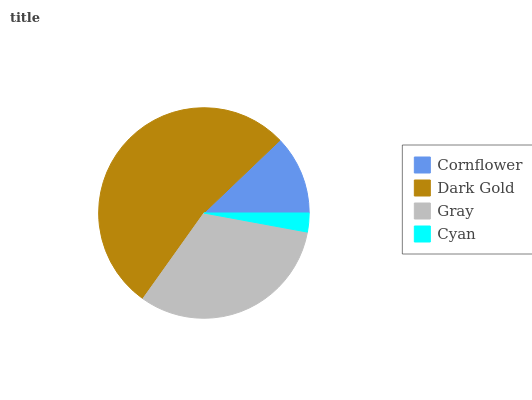Is Cyan the minimum?
Answer yes or no. Yes. Is Dark Gold the maximum?
Answer yes or no. Yes. Is Gray the minimum?
Answer yes or no. No. Is Gray the maximum?
Answer yes or no. No. Is Dark Gold greater than Gray?
Answer yes or no. Yes. Is Gray less than Dark Gold?
Answer yes or no. Yes. Is Gray greater than Dark Gold?
Answer yes or no. No. Is Dark Gold less than Gray?
Answer yes or no. No. Is Gray the high median?
Answer yes or no. Yes. Is Cornflower the low median?
Answer yes or no. Yes. Is Cyan the high median?
Answer yes or no. No. Is Gray the low median?
Answer yes or no. No. 